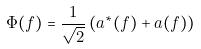Convert formula to latex. <formula><loc_0><loc_0><loc_500><loc_500>\Phi ( f ) = \frac { 1 } { \sqrt { 2 } } \left ( a ^ { * } ( f ) + a ( f ) \right )</formula> 